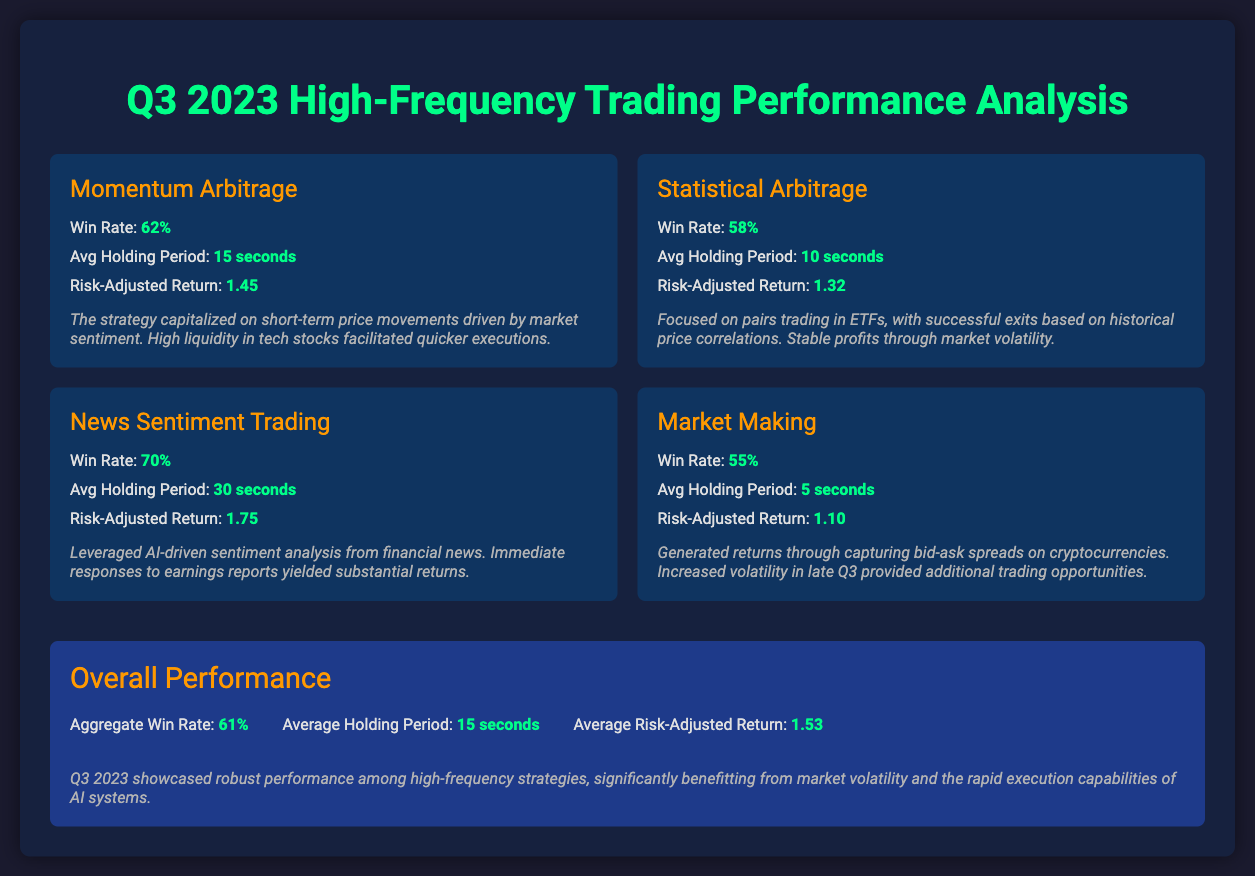What was the win rate for Momentum Arbitrage? The win rate for Momentum Arbitrage is specifically mentioned in the document as 62%.
Answer: 62% What is the average holding period for News Sentiment Trading? The document states that the average holding period for News Sentiment Trading is 30 seconds.
Answer: 30 seconds What is the overall average risk-adjusted return? The overall average risk-adjusted return can be found in the overall performance section, listed as 1.53.
Answer: 1.53 Which trading strategy had the highest win rate? By comparing the win rates presented, News Sentiment Trading has the highest win rate at 70%.
Answer: 70% What insights are provided for the Market Making strategy? The document includes key insights that describe how the Market Making strategy generated returns through capturing bid-ask spreads on cryptocurrencies.
Answer: Capturing bid-ask spreads on cryptocurrencies How long is the average holding period across all strategies? The average holding period is mentioned in the overall performance section as 15 seconds.
Answer: 15 seconds What was the win rate for Statistical Arbitrage? The document specifies that the win rate for Statistical Arbitrage is 58%.
Answer: 58% What contributed to the high performance in Q3 2023? The conclusion summarizes that robust performance was due to market volatility and rapid execution capabilities of AI systems.
Answer: Market volatility and rapid execution capabilities of AI systems 